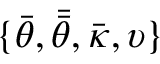<formula> <loc_0><loc_0><loc_500><loc_500>\{ \bar { \theta } , \bar { \bar { \theta } } , \bar { \kappa } , \upsilon \}</formula> 